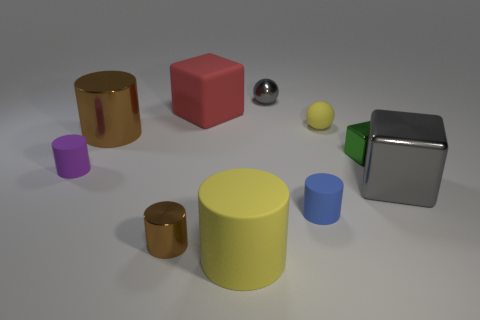Subtract all yellow cylinders. How many cylinders are left? 4 Subtract all purple blocks. How many brown cylinders are left? 2 Subtract all brown cylinders. How many cylinders are left? 3 Subtract 3 cylinders. How many cylinders are left? 2 Subtract all blocks. How many objects are left? 7 Subtract all yellow cylinders. Subtract all green balls. How many cylinders are left? 4 Add 8 yellow rubber balls. How many yellow rubber balls exist? 9 Subtract 0 purple blocks. How many objects are left? 10 Subtract all big green shiny blocks. Subtract all tiny purple matte things. How many objects are left? 9 Add 4 large brown metal cylinders. How many large brown metal cylinders are left? 5 